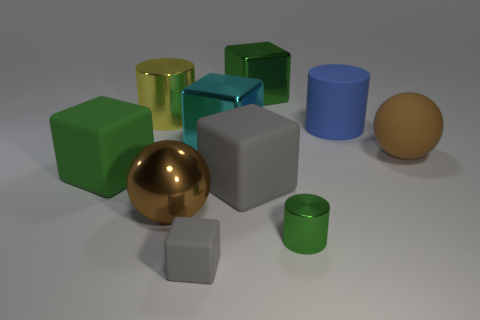What is the shape of the big thing that is in front of the cyan metallic object and right of the tiny green shiny object?
Offer a very short reply. Sphere. Is the number of big gray cubes in front of the tiny gray cube the same as the number of cylinders that are right of the big gray matte object?
Your answer should be very brief. No. Is the shape of the small object that is in front of the tiny green cylinder the same as  the big blue object?
Your answer should be very brief. No. How many yellow things are tiny matte things or shiny cylinders?
Your answer should be very brief. 1. There is another gray object that is the same shape as the small gray rubber object; what is its material?
Make the answer very short. Rubber. The green thing behind the big brown rubber ball has what shape?
Your answer should be compact. Cube. Are there any large purple objects made of the same material as the yellow thing?
Offer a very short reply. No. Is the size of the green rubber cube the same as the brown shiny ball?
Provide a succinct answer. Yes. What number of cubes are either tiny gray rubber things or large gray matte things?
Your answer should be compact. 2. There is another object that is the same color as the tiny matte thing; what is it made of?
Give a very brief answer. Rubber. 